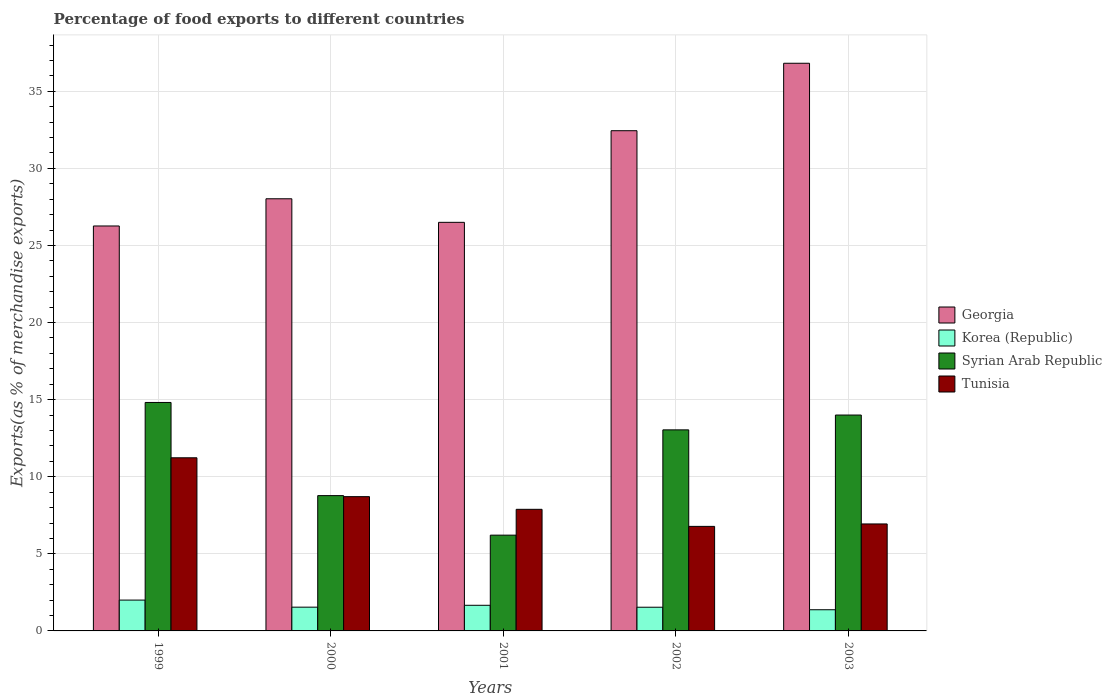How many groups of bars are there?
Give a very brief answer. 5. Are the number of bars on each tick of the X-axis equal?
Give a very brief answer. Yes. How many bars are there on the 2nd tick from the right?
Your answer should be very brief. 4. What is the label of the 4th group of bars from the left?
Your answer should be very brief. 2002. What is the percentage of exports to different countries in Korea (Republic) in 2003?
Make the answer very short. 1.37. Across all years, what is the maximum percentage of exports to different countries in Tunisia?
Your response must be concise. 11.23. Across all years, what is the minimum percentage of exports to different countries in Syrian Arab Republic?
Provide a short and direct response. 6.21. In which year was the percentage of exports to different countries in Georgia minimum?
Provide a short and direct response. 1999. What is the total percentage of exports to different countries in Korea (Republic) in the graph?
Offer a very short reply. 8.11. What is the difference between the percentage of exports to different countries in Georgia in 2000 and that in 2003?
Keep it short and to the point. -8.79. What is the difference between the percentage of exports to different countries in Tunisia in 2001 and the percentage of exports to different countries in Syrian Arab Republic in 2002?
Provide a succinct answer. -5.15. What is the average percentage of exports to different countries in Korea (Republic) per year?
Your response must be concise. 1.62. In the year 2000, what is the difference between the percentage of exports to different countries in Georgia and percentage of exports to different countries in Korea (Republic)?
Offer a very short reply. 26.49. What is the ratio of the percentage of exports to different countries in Tunisia in 1999 to that in 2002?
Keep it short and to the point. 1.66. Is the difference between the percentage of exports to different countries in Georgia in 2000 and 2002 greater than the difference between the percentage of exports to different countries in Korea (Republic) in 2000 and 2002?
Make the answer very short. No. What is the difference between the highest and the second highest percentage of exports to different countries in Syrian Arab Republic?
Your answer should be compact. 0.82. What is the difference between the highest and the lowest percentage of exports to different countries in Syrian Arab Republic?
Make the answer very short. 8.61. Is it the case that in every year, the sum of the percentage of exports to different countries in Korea (Republic) and percentage of exports to different countries in Tunisia is greater than the sum of percentage of exports to different countries in Georgia and percentage of exports to different countries in Syrian Arab Republic?
Give a very brief answer. Yes. What does the 2nd bar from the left in 2002 represents?
Give a very brief answer. Korea (Republic). What does the 1st bar from the right in 2001 represents?
Your answer should be very brief. Tunisia. Is it the case that in every year, the sum of the percentage of exports to different countries in Korea (Republic) and percentage of exports to different countries in Tunisia is greater than the percentage of exports to different countries in Georgia?
Keep it short and to the point. No. Are all the bars in the graph horizontal?
Your answer should be compact. No. Does the graph contain any zero values?
Keep it short and to the point. No. Does the graph contain grids?
Offer a very short reply. Yes. Where does the legend appear in the graph?
Offer a very short reply. Center right. How are the legend labels stacked?
Give a very brief answer. Vertical. What is the title of the graph?
Offer a very short reply. Percentage of food exports to different countries. Does "Panama" appear as one of the legend labels in the graph?
Make the answer very short. No. What is the label or title of the X-axis?
Make the answer very short. Years. What is the label or title of the Y-axis?
Provide a succinct answer. Exports(as % of merchandise exports). What is the Exports(as % of merchandise exports) in Georgia in 1999?
Your response must be concise. 26.27. What is the Exports(as % of merchandise exports) in Korea (Republic) in 1999?
Provide a succinct answer. 2. What is the Exports(as % of merchandise exports) of Syrian Arab Republic in 1999?
Offer a very short reply. 14.82. What is the Exports(as % of merchandise exports) in Tunisia in 1999?
Your answer should be very brief. 11.23. What is the Exports(as % of merchandise exports) of Georgia in 2000?
Give a very brief answer. 28.03. What is the Exports(as % of merchandise exports) in Korea (Republic) in 2000?
Offer a very short reply. 1.54. What is the Exports(as % of merchandise exports) in Syrian Arab Republic in 2000?
Make the answer very short. 8.78. What is the Exports(as % of merchandise exports) of Tunisia in 2000?
Your response must be concise. 8.71. What is the Exports(as % of merchandise exports) in Georgia in 2001?
Offer a terse response. 26.5. What is the Exports(as % of merchandise exports) in Korea (Republic) in 2001?
Your answer should be compact. 1.66. What is the Exports(as % of merchandise exports) in Syrian Arab Republic in 2001?
Ensure brevity in your answer.  6.21. What is the Exports(as % of merchandise exports) of Tunisia in 2001?
Offer a terse response. 7.89. What is the Exports(as % of merchandise exports) of Georgia in 2002?
Your response must be concise. 32.45. What is the Exports(as % of merchandise exports) of Korea (Republic) in 2002?
Offer a very short reply. 1.54. What is the Exports(as % of merchandise exports) of Syrian Arab Republic in 2002?
Your response must be concise. 13.04. What is the Exports(as % of merchandise exports) of Tunisia in 2002?
Provide a short and direct response. 6.78. What is the Exports(as % of merchandise exports) in Georgia in 2003?
Make the answer very short. 36.82. What is the Exports(as % of merchandise exports) of Korea (Republic) in 2003?
Give a very brief answer. 1.37. What is the Exports(as % of merchandise exports) in Syrian Arab Republic in 2003?
Provide a succinct answer. 14. What is the Exports(as % of merchandise exports) in Tunisia in 2003?
Give a very brief answer. 6.94. Across all years, what is the maximum Exports(as % of merchandise exports) in Georgia?
Your answer should be very brief. 36.82. Across all years, what is the maximum Exports(as % of merchandise exports) of Korea (Republic)?
Offer a very short reply. 2. Across all years, what is the maximum Exports(as % of merchandise exports) in Syrian Arab Republic?
Your response must be concise. 14.82. Across all years, what is the maximum Exports(as % of merchandise exports) of Tunisia?
Provide a succinct answer. 11.23. Across all years, what is the minimum Exports(as % of merchandise exports) of Georgia?
Provide a short and direct response. 26.27. Across all years, what is the minimum Exports(as % of merchandise exports) of Korea (Republic)?
Offer a terse response. 1.37. Across all years, what is the minimum Exports(as % of merchandise exports) of Syrian Arab Republic?
Ensure brevity in your answer.  6.21. Across all years, what is the minimum Exports(as % of merchandise exports) in Tunisia?
Make the answer very short. 6.78. What is the total Exports(as % of merchandise exports) in Georgia in the graph?
Give a very brief answer. 150.06. What is the total Exports(as % of merchandise exports) in Korea (Republic) in the graph?
Offer a very short reply. 8.11. What is the total Exports(as % of merchandise exports) of Syrian Arab Republic in the graph?
Give a very brief answer. 56.85. What is the total Exports(as % of merchandise exports) in Tunisia in the graph?
Offer a terse response. 41.55. What is the difference between the Exports(as % of merchandise exports) of Georgia in 1999 and that in 2000?
Ensure brevity in your answer.  -1.76. What is the difference between the Exports(as % of merchandise exports) in Korea (Republic) in 1999 and that in 2000?
Ensure brevity in your answer.  0.46. What is the difference between the Exports(as % of merchandise exports) in Syrian Arab Republic in 1999 and that in 2000?
Your answer should be compact. 6.04. What is the difference between the Exports(as % of merchandise exports) of Tunisia in 1999 and that in 2000?
Ensure brevity in your answer.  2.52. What is the difference between the Exports(as % of merchandise exports) in Georgia in 1999 and that in 2001?
Your answer should be compact. -0.24. What is the difference between the Exports(as % of merchandise exports) in Korea (Republic) in 1999 and that in 2001?
Your response must be concise. 0.34. What is the difference between the Exports(as % of merchandise exports) of Syrian Arab Republic in 1999 and that in 2001?
Keep it short and to the point. 8.61. What is the difference between the Exports(as % of merchandise exports) of Tunisia in 1999 and that in 2001?
Provide a short and direct response. 3.34. What is the difference between the Exports(as % of merchandise exports) in Georgia in 1999 and that in 2002?
Your answer should be very brief. -6.18. What is the difference between the Exports(as % of merchandise exports) in Korea (Republic) in 1999 and that in 2002?
Ensure brevity in your answer.  0.46. What is the difference between the Exports(as % of merchandise exports) in Syrian Arab Republic in 1999 and that in 2002?
Give a very brief answer. 1.78. What is the difference between the Exports(as % of merchandise exports) in Tunisia in 1999 and that in 2002?
Offer a very short reply. 4.45. What is the difference between the Exports(as % of merchandise exports) of Georgia in 1999 and that in 2003?
Provide a short and direct response. -10.55. What is the difference between the Exports(as % of merchandise exports) in Korea (Republic) in 1999 and that in 2003?
Provide a short and direct response. 0.63. What is the difference between the Exports(as % of merchandise exports) of Syrian Arab Republic in 1999 and that in 2003?
Make the answer very short. 0.82. What is the difference between the Exports(as % of merchandise exports) in Tunisia in 1999 and that in 2003?
Provide a succinct answer. 4.29. What is the difference between the Exports(as % of merchandise exports) of Georgia in 2000 and that in 2001?
Your answer should be compact. 1.53. What is the difference between the Exports(as % of merchandise exports) in Korea (Republic) in 2000 and that in 2001?
Make the answer very short. -0.12. What is the difference between the Exports(as % of merchandise exports) in Syrian Arab Republic in 2000 and that in 2001?
Make the answer very short. 2.56. What is the difference between the Exports(as % of merchandise exports) of Tunisia in 2000 and that in 2001?
Give a very brief answer. 0.82. What is the difference between the Exports(as % of merchandise exports) in Georgia in 2000 and that in 2002?
Provide a short and direct response. -4.42. What is the difference between the Exports(as % of merchandise exports) in Korea (Republic) in 2000 and that in 2002?
Provide a short and direct response. 0. What is the difference between the Exports(as % of merchandise exports) in Syrian Arab Republic in 2000 and that in 2002?
Offer a terse response. -4.27. What is the difference between the Exports(as % of merchandise exports) in Tunisia in 2000 and that in 2002?
Your answer should be very brief. 1.93. What is the difference between the Exports(as % of merchandise exports) of Georgia in 2000 and that in 2003?
Your answer should be very brief. -8.79. What is the difference between the Exports(as % of merchandise exports) of Korea (Republic) in 2000 and that in 2003?
Ensure brevity in your answer.  0.17. What is the difference between the Exports(as % of merchandise exports) in Syrian Arab Republic in 2000 and that in 2003?
Offer a very short reply. -5.23. What is the difference between the Exports(as % of merchandise exports) of Tunisia in 2000 and that in 2003?
Make the answer very short. 1.77. What is the difference between the Exports(as % of merchandise exports) of Georgia in 2001 and that in 2002?
Your answer should be compact. -5.94. What is the difference between the Exports(as % of merchandise exports) in Korea (Republic) in 2001 and that in 2002?
Keep it short and to the point. 0.13. What is the difference between the Exports(as % of merchandise exports) of Syrian Arab Republic in 2001 and that in 2002?
Your answer should be compact. -6.83. What is the difference between the Exports(as % of merchandise exports) of Tunisia in 2001 and that in 2002?
Provide a short and direct response. 1.11. What is the difference between the Exports(as % of merchandise exports) of Georgia in 2001 and that in 2003?
Keep it short and to the point. -10.32. What is the difference between the Exports(as % of merchandise exports) in Korea (Republic) in 2001 and that in 2003?
Keep it short and to the point. 0.29. What is the difference between the Exports(as % of merchandise exports) of Syrian Arab Republic in 2001 and that in 2003?
Keep it short and to the point. -7.79. What is the difference between the Exports(as % of merchandise exports) of Tunisia in 2001 and that in 2003?
Ensure brevity in your answer.  0.95. What is the difference between the Exports(as % of merchandise exports) in Georgia in 2002 and that in 2003?
Provide a succinct answer. -4.37. What is the difference between the Exports(as % of merchandise exports) in Korea (Republic) in 2002 and that in 2003?
Provide a short and direct response. 0.16. What is the difference between the Exports(as % of merchandise exports) of Syrian Arab Republic in 2002 and that in 2003?
Offer a very short reply. -0.96. What is the difference between the Exports(as % of merchandise exports) in Tunisia in 2002 and that in 2003?
Offer a very short reply. -0.16. What is the difference between the Exports(as % of merchandise exports) in Georgia in 1999 and the Exports(as % of merchandise exports) in Korea (Republic) in 2000?
Your answer should be very brief. 24.72. What is the difference between the Exports(as % of merchandise exports) of Georgia in 1999 and the Exports(as % of merchandise exports) of Syrian Arab Republic in 2000?
Your answer should be very brief. 17.49. What is the difference between the Exports(as % of merchandise exports) of Georgia in 1999 and the Exports(as % of merchandise exports) of Tunisia in 2000?
Keep it short and to the point. 17.56. What is the difference between the Exports(as % of merchandise exports) of Korea (Republic) in 1999 and the Exports(as % of merchandise exports) of Syrian Arab Republic in 2000?
Ensure brevity in your answer.  -6.78. What is the difference between the Exports(as % of merchandise exports) of Korea (Republic) in 1999 and the Exports(as % of merchandise exports) of Tunisia in 2000?
Make the answer very short. -6.71. What is the difference between the Exports(as % of merchandise exports) in Syrian Arab Republic in 1999 and the Exports(as % of merchandise exports) in Tunisia in 2000?
Your response must be concise. 6.11. What is the difference between the Exports(as % of merchandise exports) of Georgia in 1999 and the Exports(as % of merchandise exports) of Korea (Republic) in 2001?
Make the answer very short. 24.6. What is the difference between the Exports(as % of merchandise exports) of Georgia in 1999 and the Exports(as % of merchandise exports) of Syrian Arab Republic in 2001?
Offer a very short reply. 20.05. What is the difference between the Exports(as % of merchandise exports) of Georgia in 1999 and the Exports(as % of merchandise exports) of Tunisia in 2001?
Keep it short and to the point. 18.38. What is the difference between the Exports(as % of merchandise exports) of Korea (Republic) in 1999 and the Exports(as % of merchandise exports) of Syrian Arab Republic in 2001?
Your response must be concise. -4.21. What is the difference between the Exports(as % of merchandise exports) in Korea (Republic) in 1999 and the Exports(as % of merchandise exports) in Tunisia in 2001?
Provide a short and direct response. -5.89. What is the difference between the Exports(as % of merchandise exports) of Syrian Arab Republic in 1999 and the Exports(as % of merchandise exports) of Tunisia in 2001?
Make the answer very short. 6.93. What is the difference between the Exports(as % of merchandise exports) in Georgia in 1999 and the Exports(as % of merchandise exports) in Korea (Republic) in 2002?
Give a very brief answer. 24.73. What is the difference between the Exports(as % of merchandise exports) of Georgia in 1999 and the Exports(as % of merchandise exports) of Syrian Arab Republic in 2002?
Provide a short and direct response. 13.22. What is the difference between the Exports(as % of merchandise exports) of Georgia in 1999 and the Exports(as % of merchandise exports) of Tunisia in 2002?
Give a very brief answer. 19.48. What is the difference between the Exports(as % of merchandise exports) in Korea (Republic) in 1999 and the Exports(as % of merchandise exports) in Syrian Arab Republic in 2002?
Your response must be concise. -11.04. What is the difference between the Exports(as % of merchandise exports) of Korea (Republic) in 1999 and the Exports(as % of merchandise exports) of Tunisia in 2002?
Your answer should be very brief. -4.78. What is the difference between the Exports(as % of merchandise exports) in Syrian Arab Republic in 1999 and the Exports(as % of merchandise exports) in Tunisia in 2002?
Your answer should be very brief. 8.04. What is the difference between the Exports(as % of merchandise exports) of Georgia in 1999 and the Exports(as % of merchandise exports) of Korea (Republic) in 2003?
Keep it short and to the point. 24.89. What is the difference between the Exports(as % of merchandise exports) in Georgia in 1999 and the Exports(as % of merchandise exports) in Syrian Arab Republic in 2003?
Offer a terse response. 12.26. What is the difference between the Exports(as % of merchandise exports) in Georgia in 1999 and the Exports(as % of merchandise exports) in Tunisia in 2003?
Your answer should be very brief. 19.33. What is the difference between the Exports(as % of merchandise exports) in Korea (Republic) in 1999 and the Exports(as % of merchandise exports) in Syrian Arab Republic in 2003?
Your response must be concise. -12. What is the difference between the Exports(as % of merchandise exports) of Korea (Republic) in 1999 and the Exports(as % of merchandise exports) of Tunisia in 2003?
Your answer should be very brief. -4.94. What is the difference between the Exports(as % of merchandise exports) in Syrian Arab Republic in 1999 and the Exports(as % of merchandise exports) in Tunisia in 2003?
Make the answer very short. 7.88. What is the difference between the Exports(as % of merchandise exports) of Georgia in 2000 and the Exports(as % of merchandise exports) of Korea (Republic) in 2001?
Make the answer very short. 26.37. What is the difference between the Exports(as % of merchandise exports) of Georgia in 2000 and the Exports(as % of merchandise exports) of Syrian Arab Republic in 2001?
Your response must be concise. 21.82. What is the difference between the Exports(as % of merchandise exports) in Georgia in 2000 and the Exports(as % of merchandise exports) in Tunisia in 2001?
Make the answer very short. 20.14. What is the difference between the Exports(as % of merchandise exports) of Korea (Republic) in 2000 and the Exports(as % of merchandise exports) of Syrian Arab Republic in 2001?
Ensure brevity in your answer.  -4.67. What is the difference between the Exports(as % of merchandise exports) in Korea (Republic) in 2000 and the Exports(as % of merchandise exports) in Tunisia in 2001?
Offer a terse response. -6.35. What is the difference between the Exports(as % of merchandise exports) in Syrian Arab Republic in 2000 and the Exports(as % of merchandise exports) in Tunisia in 2001?
Make the answer very short. 0.89. What is the difference between the Exports(as % of merchandise exports) of Georgia in 2000 and the Exports(as % of merchandise exports) of Korea (Republic) in 2002?
Provide a short and direct response. 26.49. What is the difference between the Exports(as % of merchandise exports) of Georgia in 2000 and the Exports(as % of merchandise exports) of Syrian Arab Republic in 2002?
Provide a succinct answer. 14.99. What is the difference between the Exports(as % of merchandise exports) in Georgia in 2000 and the Exports(as % of merchandise exports) in Tunisia in 2002?
Give a very brief answer. 21.25. What is the difference between the Exports(as % of merchandise exports) in Korea (Republic) in 2000 and the Exports(as % of merchandise exports) in Syrian Arab Republic in 2002?
Ensure brevity in your answer.  -11.5. What is the difference between the Exports(as % of merchandise exports) in Korea (Republic) in 2000 and the Exports(as % of merchandise exports) in Tunisia in 2002?
Provide a succinct answer. -5.24. What is the difference between the Exports(as % of merchandise exports) of Syrian Arab Republic in 2000 and the Exports(as % of merchandise exports) of Tunisia in 2002?
Offer a terse response. 2. What is the difference between the Exports(as % of merchandise exports) of Georgia in 2000 and the Exports(as % of merchandise exports) of Korea (Republic) in 2003?
Offer a terse response. 26.66. What is the difference between the Exports(as % of merchandise exports) of Georgia in 2000 and the Exports(as % of merchandise exports) of Syrian Arab Republic in 2003?
Offer a very short reply. 14.03. What is the difference between the Exports(as % of merchandise exports) in Georgia in 2000 and the Exports(as % of merchandise exports) in Tunisia in 2003?
Provide a succinct answer. 21.09. What is the difference between the Exports(as % of merchandise exports) in Korea (Republic) in 2000 and the Exports(as % of merchandise exports) in Syrian Arab Republic in 2003?
Offer a very short reply. -12.46. What is the difference between the Exports(as % of merchandise exports) of Korea (Republic) in 2000 and the Exports(as % of merchandise exports) of Tunisia in 2003?
Offer a very short reply. -5.4. What is the difference between the Exports(as % of merchandise exports) of Syrian Arab Republic in 2000 and the Exports(as % of merchandise exports) of Tunisia in 2003?
Your answer should be compact. 1.84. What is the difference between the Exports(as % of merchandise exports) of Georgia in 2001 and the Exports(as % of merchandise exports) of Korea (Republic) in 2002?
Offer a very short reply. 24.97. What is the difference between the Exports(as % of merchandise exports) of Georgia in 2001 and the Exports(as % of merchandise exports) of Syrian Arab Republic in 2002?
Provide a succinct answer. 13.46. What is the difference between the Exports(as % of merchandise exports) in Georgia in 2001 and the Exports(as % of merchandise exports) in Tunisia in 2002?
Offer a very short reply. 19.72. What is the difference between the Exports(as % of merchandise exports) of Korea (Republic) in 2001 and the Exports(as % of merchandise exports) of Syrian Arab Republic in 2002?
Your answer should be very brief. -11.38. What is the difference between the Exports(as % of merchandise exports) of Korea (Republic) in 2001 and the Exports(as % of merchandise exports) of Tunisia in 2002?
Ensure brevity in your answer.  -5.12. What is the difference between the Exports(as % of merchandise exports) in Syrian Arab Republic in 2001 and the Exports(as % of merchandise exports) in Tunisia in 2002?
Offer a very short reply. -0.57. What is the difference between the Exports(as % of merchandise exports) in Georgia in 2001 and the Exports(as % of merchandise exports) in Korea (Republic) in 2003?
Your response must be concise. 25.13. What is the difference between the Exports(as % of merchandise exports) of Georgia in 2001 and the Exports(as % of merchandise exports) of Syrian Arab Republic in 2003?
Your response must be concise. 12.5. What is the difference between the Exports(as % of merchandise exports) in Georgia in 2001 and the Exports(as % of merchandise exports) in Tunisia in 2003?
Make the answer very short. 19.56. What is the difference between the Exports(as % of merchandise exports) of Korea (Republic) in 2001 and the Exports(as % of merchandise exports) of Syrian Arab Republic in 2003?
Offer a very short reply. -12.34. What is the difference between the Exports(as % of merchandise exports) in Korea (Republic) in 2001 and the Exports(as % of merchandise exports) in Tunisia in 2003?
Offer a very short reply. -5.28. What is the difference between the Exports(as % of merchandise exports) in Syrian Arab Republic in 2001 and the Exports(as % of merchandise exports) in Tunisia in 2003?
Give a very brief answer. -0.73. What is the difference between the Exports(as % of merchandise exports) of Georgia in 2002 and the Exports(as % of merchandise exports) of Korea (Republic) in 2003?
Make the answer very short. 31.07. What is the difference between the Exports(as % of merchandise exports) in Georgia in 2002 and the Exports(as % of merchandise exports) in Syrian Arab Republic in 2003?
Provide a succinct answer. 18.44. What is the difference between the Exports(as % of merchandise exports) of Georgia in 2002 and the Exports(as % of merchandise exports) of Tunisia in 2003?
Offer a very short reply. 25.51. What is the difference between the Exports(as % of merchandise exports) in Korea (Republic) in 2002 and the Exports(as % of merchandise exports) in Syrian Arab Republic in 2003?
Your answer should be very brief. -12.47. What is the difference between the Exports(as % of merchandise exports) in Korea (Republic) in 2002 and the Exports(as % of merchandise exports) in Tunisia in 2003?
Give a very brief answer. -5.4. What is the difference between the Exports(as % of merchandise exports) in Syrian Arab Republic in 2002 and the Exports(as % of merchandise exports) in Tunisia in 2003?
Your answer should be compact. 6.1. What is the average Exports(as % of merchandise exports) in Georgia per year?
Offer a terse response. 30.01. What is the average Exports(as % of merchandise exports) in Korea (Republic) per year?
Keep it short and to the point. 1.62. What is the average Exports(as % of merchandise exports) of Syrian Arab Republic per year?
Keep it short and to the point. 11.37. What is the average Exports(as % of merchandise exports) of Tunisia per year?
Your answer should be very brief. 8.31. In the year 1999, what is the difference between the Exports(as % of merchandise exports) in Georgia and Exports(as % of merchandise exports) in Korea (Republic)?
Offer a very short reply. 24.27. In the year 1999, what is the difference between the Exports(as % of merchandise exports) in Georgia and Exports(as % of merchandise exports) in Syrian Arab Republic?
Make the answer very short. 11.45. In the year 1999, what is the difference between the Exports(as % of merchandise exports) of Georgia and Exports(as % of merchandise exports) of Tunisia?
Your response must be concise. 15.04. In the year 1999, what is the difference between the Exports(as % of merchandise exports) in Korea (Republic) and Exports(as % of merchandise exports) in Syrian Arab Republic?
Offer a very short reply. -12.82. In the year 1999, what is the difference between the Exports(as % of merchandise exports) of Korea (Republic) and Exports(as % of merchandise exports) of Tunisia?
Your answer should be very brief. -9.23. In the year 1999, what is the difference between the Exports(as % of merchandise exports) in Syrian Arab Republic and Exports(as % of merchandise exports) in Tunisia?
Ensure brevity in your answer.  3.59. In the year 2000, what is the difference between the Exports(as % of merchandise exports) in Georgia and Exports(as % of merchandise exports) in Korea (Republic)?
Your response must be concise. 26.49. In the year 2000, what is the difference between the Exports(as % of merchandise exports) of Georgia and Exports(as % of merchandise exports) of Syrian Arab Republic?
Provide a short and direct response. 19.25. In the year 2000, what is the difference between the Exports(as % of merchandise exports) in Georgia and Exports(as % of merchandise exports) in Tunisia?
Your answer should be very brief. 19.32. In the year 2000, what is the difference between the Exports(as % of merchandise exports) in Korea (Republic) and Exports(as % of merchandise exports) in Syrian Arab Republic?
Your response must be concise. -7.24. In the year 2000, what is the difference between the Exports(as % of merchandise exports) in Korea (Republic) and Exports(as % of merchandise exports) in Tunisia?
Your response must be concise. -7.17. In the year 2000, what is the difference between the Exports(as % of merchandise exports) of Syrian Arab Republic and Exports(as % of merchandise exports) of Tunisia?
Offer a very short reply. 0.07. In the year 2001, what is the difference between the Exports(as % of merchandise exports) of Georgia and Exports(as % of merchandise exports) of Korea (Republic)?
Provide a short and direct response. 24.84. In the year 2001, what is the difference between the Exports(as % of merchandise exports) of Georgia and Exports(as % of merchandise exports) of Syrian Arab Republic?
Ensure brevity in your answer.  20.29. In the year 2001, what is the difference between the Exports(as % of merchandise exports) in Georgia and Exports(as % of merchandise exports) in Tunisia?
Your response must be concise. 18.61. In the year 2001, what is the difference between the Exports(as % of merchandise exports) in Korea (Republic) and Exports(as % of merchandise exports) in Syrian Arab Republic?
Offer a terse response. -4.55. In the year 2001, what is the difference between the Exports(as % of merchandise exports) of Korea (Republic) and Exports(as % of merchandise exports) of Tunisia?
Offer a very short reply. -6.22. In the year 2001, what is the difference between the Exports(as % of merchandise exports) of Syrian Arab Republic and Exports(as % of merchandise exports) of Tunisia?
Keep it short and to the point. -1.68. In the year 2002, what is the difference between the Exports(as % of merchandise exports) in Georgia and Exports(as % of merchandise exports) in Korea (Republic)?
Ensure brevity in your answer.  30.91. In the year 2002, what is the difference between the Exports(as % of merchandise exports) in Georgia and Exports(as % of merchandise exports) in Syrian Arab Republic?
Your answer should be very brief. 19.4. In the year 2002, what is the difference between the Exports(as % of merchandise exports) in Georgia and Exports(as % of merchandise exports) in Tunisia?
Keep it short and to the point. 25.66. In the year 2002, what is the difference between the Exports(as % of merchandise exports) of Korea (Republic) and Exports(as % of merchandise exports) of Syrian Arab Republic?
Provide a short and direct response. -11.5. In the year 2002, what is the difference between the Exports(as % of merchandise exports) in Korea (Republic) and Exports(as % of merchandise exports) in Tunisia?
Make the answer very short. -5.24. In the year 2002, what is the difference between the Exports(as % of merchandise exports) of Syrian Arab Republic and Exports(as % of merchandise exports) of Tunisia?
Your response must be concise. 6.26. In the year 2003, what is the difference between the Exports(as % of merchandise exports) in Georgia and Exports(as % of merchandise exports) in Korea (Republic)?
Ensure brevity in your answer.  35.45. In the year 2003, what is the difference between the Exports(as % of merchandise exports) of Georgia and Exports(as % of merchandise exports) of Syrian Arab Republic?
Ensure brevity in your answer.  22.82. In the year 2003, what is the difference between the Exports(as % of merchandise exports) of Georgia and Exports(as % of merchandise exports) of Tunisia?
Keep it short and to the point. 29.88. In the year 2003, what is the difference between the Exports(as % of merchandise exports) of Korea (Republic) and Exports(as % of merchandise exports) of Syrian Arab Republic?
Provide a succinct answer. -12.63. In the year 2003, what is the difference between the Exports(as % of merchandise exports) in Korea (Republic) and Exports(as % of merchandise exports) in Tunisia?
Keep it short and to the point. -5.57. In the year 2003, what is the difference between the Exports(as % of merchandise exports) in Syrian Arab Republic and Exports(as % of merchandise exports) in Tunisia?
Ensure brevity in your answer.  7.06. What is the ratio of the Exports(as % of merchandise exports) in Georgia in 1999 to that in 2000?
Offer a terse response. 0.94. What is the ratio of the Exports(as % of merchandise exports) in Korea (Republic) in 1999 to that in 2000?
Provide a succinct answer. 1.3. What is the ratio of the Exports(as % of merchandise exports) in Syrian Arab Republic in 1999 to that in 2000?
Offer a very short reply. 1.69. What is the ratio of the Exports(as % of merchandise exports) of Tunisia in 1999 to that in 2000?
Offer a very short reply. 1.29. What is the ratio of the Exports(as % of merchandise exports) of Georgia in 1999 to that in 2001?
Ensure brevity in your answer.  0.99. What is the ratio of the Exports(as % of merchandise exports) in Korea (Republic) in 1999 to that in 2001?
Make the answer very short. 1.2. What is the ratio of the Exports(as % of merchandise exports) of Syrian Arab Republic in 1999 to that in 2001?
Your answer should be very brief. 2.39. What is the ratio of the Exports(as % of merchandise exports) of Tunisia in 1999 to that in 2001?
Provide a succinct answer. 1.42. What is the ratio of the Exports(as % of merchandise exports) of Georgia in 1999 to that in 2002?
Offer a very short reply. 0.81. What is the ratio of the Exports(as % of merchandise exports) of Korea (Republic) in 1999 to that in 2002?
Keep it short and to the point. 1.3. What is the ratio of the Exports(as % of merchandise exports) of Syrian Arab Republic in 1999 to that in 2002?
Ensure brevity in your answer.  1.14. What is the ratio of the Exports(as % of merchandise exports) of Tunisia in 1999 to that in 2002?
Make the answer very short. 1.66. What is the ratio of the Exports(as % of merchandise exports) in Georgia in 1999 to that in 2003?
Your response must be concise. 0.71. What is the ratio of the Exports(as % of merchandise exports) in Korea (Republic) in 1999 to that in 2003?
Ensure brevity in your answer.  1.46. What is the ratio of the Exports(as % of merchandise exports) of Syrian Arab Republic in 1999 to that in 2003?
Ensure brevity in your answer.  1.06. What is the ratio of the Exports(as % of merchandise exports) of Tunisia in 1999 to that in 2003?
Your answer should be very brief. 1.62. What is the ratio of the Exports(as % of merchandise exports) of Georgia in 2000 to that in 2001?
Give a very brief answer. 1.06. What is the ratio of the Exports(as % of merchandise exports) of Korea (Republic) in 2000 to that in 2001?
Your response must be concise. 0.93. What is the ratio of the Exports(as % of merchandise exports) in Syrian Arab Republic in 2000 to that in 2001?
Offer a terse response. 1.41. What is the ratio of the Exports(as % of merchandise exports) in Tunisia in 2000 to that in 2001?
Make the answer very short. 1.1. What is the ratio of the Exports(as % of merchandise exports) of Georgia in 2000 to that in 2002?
Your answer should be compact. 0.86. What is the ratio of the Exports(as % of merchandise exports) of Syrian Arab Republic in 2000 to that in 2002?
Give a very brief answer. 0.67. What is the ratio of the Exports(as % of merchandise exports) in Tunisia in 2000 to that in 2002?
Make the answer very short. 1.28. What is the ratio of the Exports(as % of merchandise exports) in Georgia in 2000 to that in 2003?
Your answer should be very brief. 0.76. What is the ratio of the Exports(as % of merchandise exports) in Korea (Republic) in 2000 to that in 2003?
Give a very brief answer. 1.12. What is the ratio of the Exports(as % of merchandise exports) of Syrian Arab Republic in 2000 to that in 2003?
Your response must be concise. 0.63. What is the ratio of the Exports(as % of merchandise exports) in Tunisia in 2000 to that in 2003?
Your response must be concise. 1.26. What is the ratio of the Exports(as % of merchandise exports) in Georgia in 2001 to that in 2002?
Offer a terse response. 0.82. What is the ratio of the Exports(as % of merchandise exports) in Korea (Republic) in 2001 to that in 2002?
Offer a terse response. 1.08. What is the ratio of the Exports(as % of merchandise exports) in Syrian Arab Republic in 2001 to that in 2002?
Provide a succinct answer. 0.48. What is the ratio of the Exports(as % of merchandise exports) of Tunisia in 2001 to that in 2002?
Your answer should be very brief. 1.16. What is the ratio of the Exports(as % of merchandise exports) in Georgia in 2001 to that in 2003?
Offer a very short reply. 0.72. What is the ratio of the Exports(as % of merchandise exports) in Korea (Republic) in 2001 to that in 2003?
Make the answer very short. 1.21. What is the ratio of the Exports(as % of merchandise exports) of Syrian Arab Republic in 2001 to that in 2003?
Offer a very short reply. 0.44. What is the ratio of the Exports(as % of merchandise exports) in Tunisia in 2001 to that in 2003?
Your answer should be very brief. 1.14. What is the ratio of the Exports(as % of merchandise exports) of Georgia in 2002 to that in 2003?
Provide a succinct answer. 0.88. What is the ratio of the Exports(as % of merchandise exports) of Korea (Republic) in 2002 to that in 2003?
Keep it short and to the point. 1.12. What is the ratio of the Exports(as % of merchandise exports) of Syrian Arab Republic in 2002 to that in 2003?
Make the answer very short. 0.93. What is the ratio of the Exports(as % of merchandise exports) of Tunisia in 2002 to that in 2003?
Offer a very short reply. 0.98. What is the difference between the highest and the second highest Exports(as % of merchandise exports) of Georgia?
Your answer should be compact. 4.37. What is the difference between the highest and the second highest Exports(as % of merchandise exports) of Korea (Republic)?
Provide a succinct answer. 0.34. What is the difference between the highest and the second highest Exports(as % of merchandise exports) of Syrian Arab Republic?
Keep it short and to the point. 0.82. What is the difference between the highest and the second highest Exports(as % of merchandise exports) of Tunisia?
Keep it short and to the point. 2.52. What is the difference between the highest and the lowest Exports(as % of merchandise exports) in Georgia?
Your answer should be very brief. 10.55. What is the difference between the highest and the lowest Exports(as % of merchandise exports) of Korea (Republic)?
Your response must be concise. 0.63. What is the difference between the highest and the lowest Exports(as % of merchandise exports) in Syrian Arab Republic?
Provide a succinct answer. 8.61. What is the difference between the highest and the lowest Exports(as % of merchandise exports) of Tunisia?
Offer a very short reply. 4.45. 